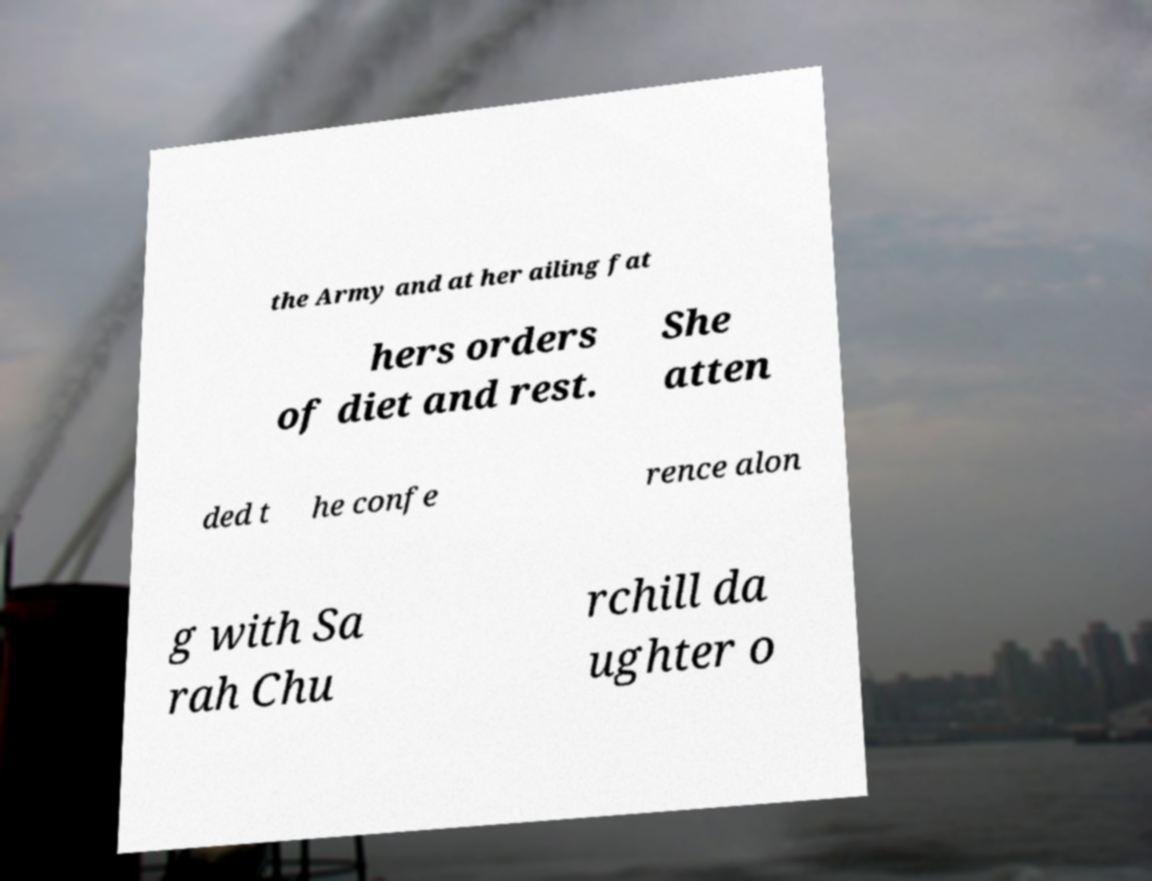Please read and relay the text visible in this image. What does it say? the Army and at her ailing fat hers orders of diet and rest. She atten ded t he confe rence alon g with Sa rah Chu rchill da ughter o 